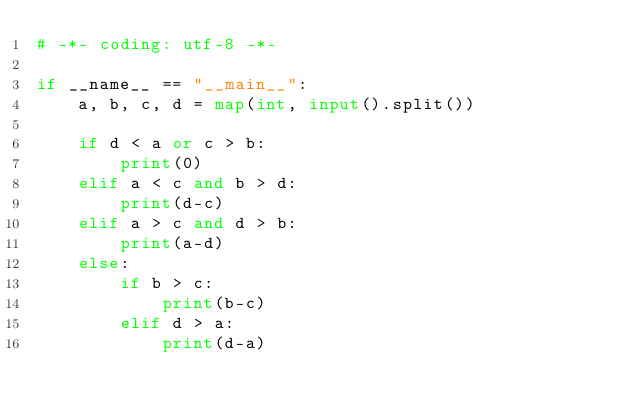Convert code to text. <code><loc_0><loc_0><loc_500><loc_500><_Python_># -*- coding: utf-8 -*-

if __name__ == "__main__":
    a, b, c, d = map(int, input().split())

    if d < a or c > b:
        print(0)
    elif a < c and b > d:
        print(d-c)
    elif a > c and d > b:
        print(a-d)
    else:
        if b > c:
            print(b-c)
        elif d > a:
            print(d-a)
</code> 